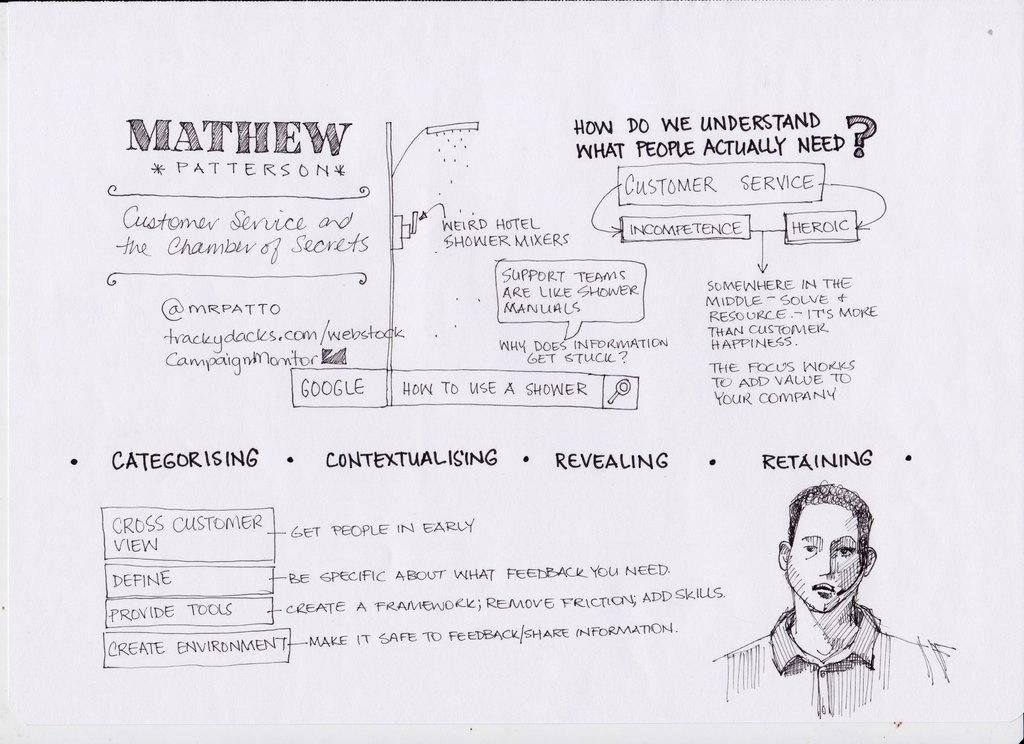What is the main subject of the writing on the white surface in the image? The facts provided do not specify the content of the writing, so we cannot determine the main subject. Can you describe the drawing of a person in the image? The facts provided do not specify the details of the drawing, so we cannot describe it. What route does the knife take to reach the order in the image? There is no knife or order present in the image, so this question cannot be answered. 